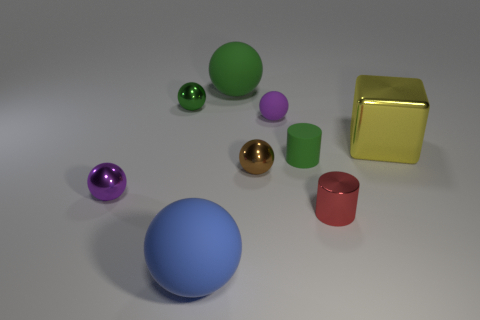Does the tiny green object that is to the left of the blue matte object have the same shape as the large rubber object behind the block?
Your answer should be compact. Yes. What number of blocks are green metal things or brown metal objects?
Your response must be concise. 0. Are there fewer tiny purple matte spheres to the left of the yellow cube than small green matte cubes?
Provide a succinct answer. No. What number of other things are there of the same material as the large yellow block
Ensure brevity in your answer.  4. Is the blue object the same size as the brown metallic sphere?
Keep it short and to the point. No. What number of objects are green cylinders left of the small red shiny thing or blocks?
Make the answer very short. 2. There is a tiny purple ball that is right of the purple object that is in front of the shiny cube; what is its material?
Keep it short and to the point. Rubber. Is there a big yellow metallic thing of the same shape as the brown object?
Provide a short and direct response. No. There is a brown ball; is its size the same as the metal sphere that is in front of the brown shiny sphere?
Ensure brevity in your answer.  Yes. What number of things are tiny brown metal things on the right side of the green rubber sphere or large things behind the blue matte sphere?
Give a very brief answer. 3. 